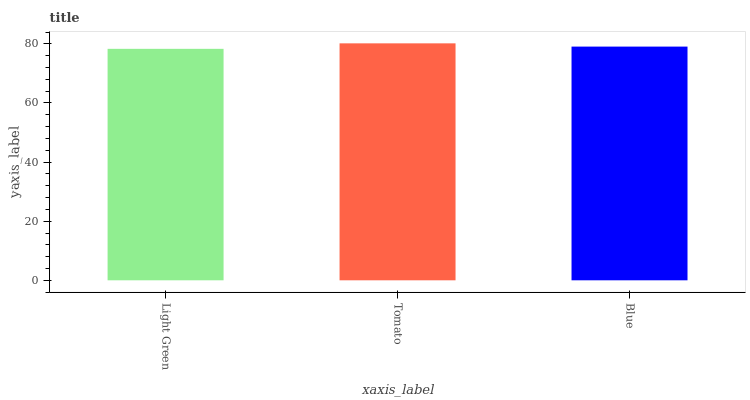Is Blue the minimum?
Answer yes or no. No. Is Blue the maximum?
Answer yes or no. No. Is Tomato greater than Blue?
Answer yes or no. Yes. Is Blue less than Tomato?
Answer yes or no. Yes. Is Blue greater than Tomato?
Answer yes or no. No. Is Tomato less than Blue?
Answer yes or no. No. Is Blue the high median?
Answer yes or no. Yes. Is Blue the low median?
Answer yes or no. Yes. Is Light Green the high median?
Answer yes or no. No. Is Tomato the low median?
Answer yes or no. No. 